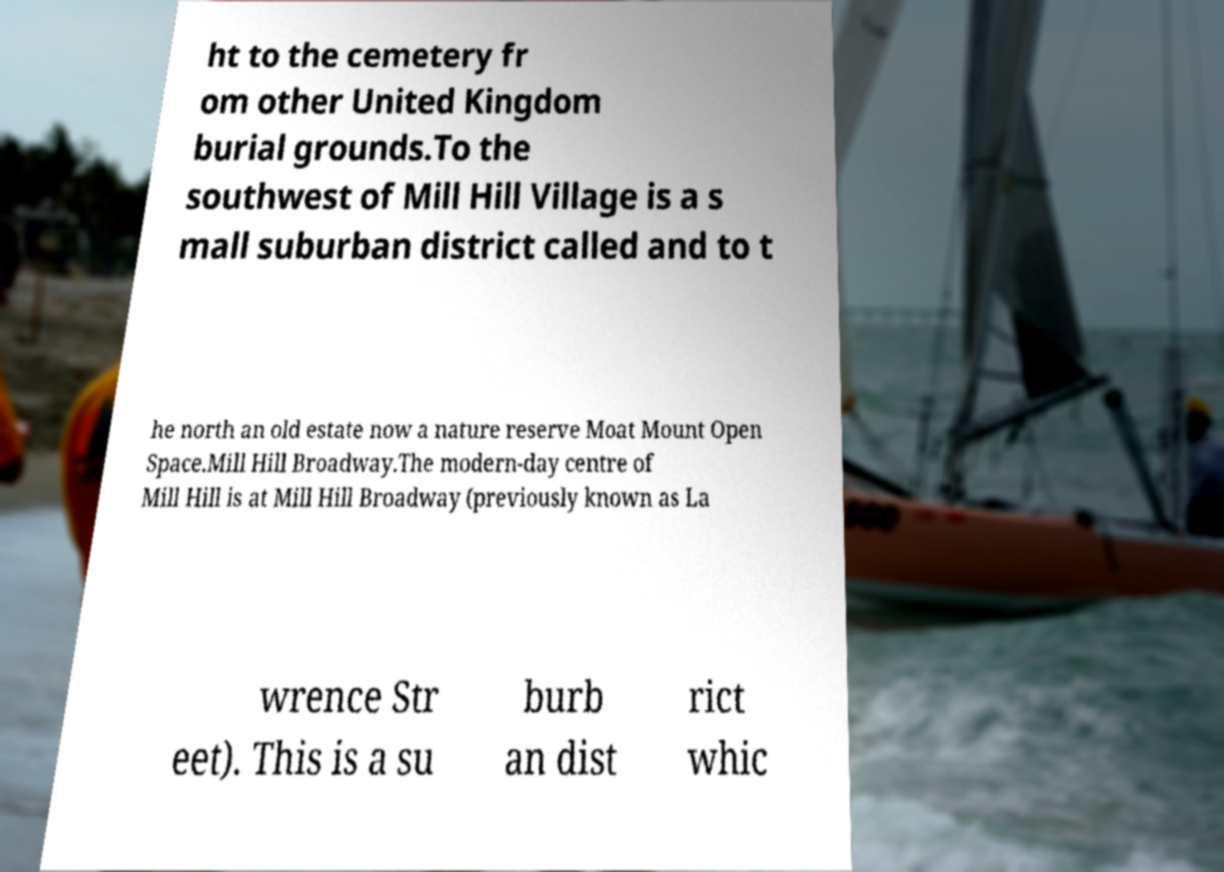Can you accurately transcribe the text from the provided image for me? ht to the cemetery fr om other United Kingdom burial grounds.To the southwest of Mill Hill Village is a s mall suburban district called and to t he north an old estate now a nature reserve Moat Mount Open Space.Mill Hill Broadway.The modern-day centre of Mill Hill is at Mill Hill Broadway (previously known as La wrence Str eet). This is a su burb an dist rict whic 